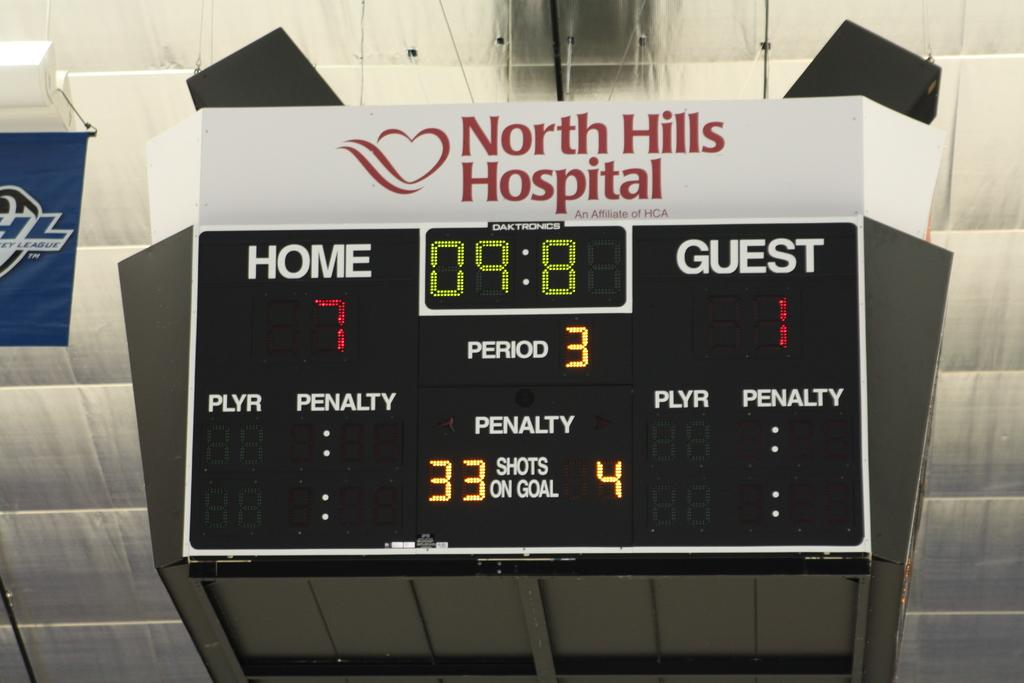<image>
Give a short and clear explanation of the subsequent image. North Hills hospital sign is above a score board 